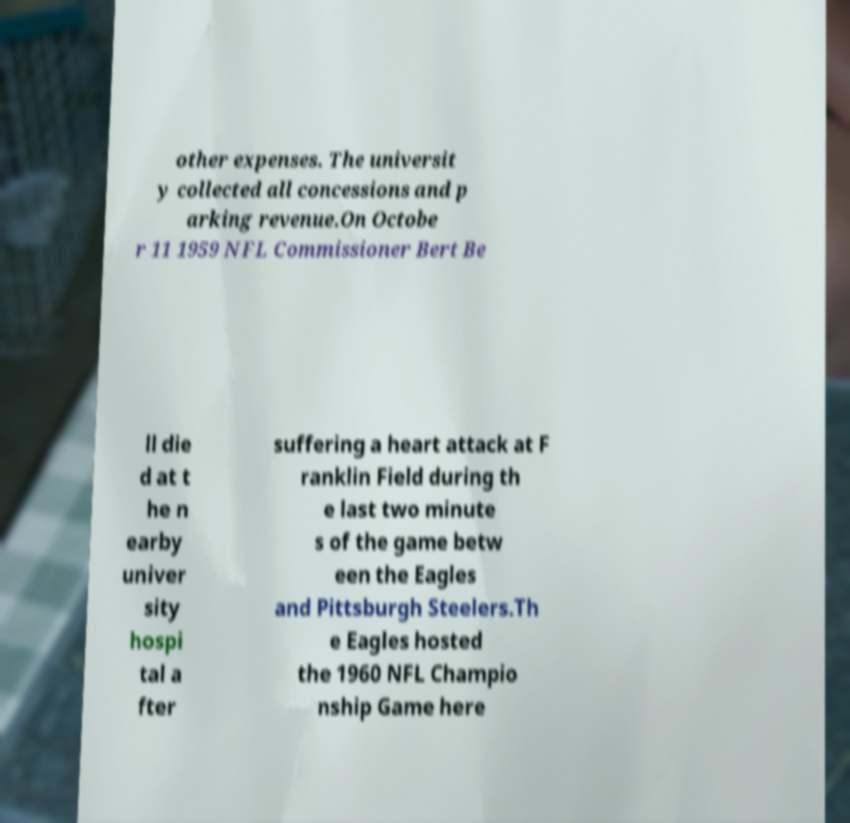Can you accurately transcribe the text from the provided image for me? other expenses. The universit y collected all concessions and p arking revenue.On Octobe r 11 1959 NFL Commissioner Bert Be ll die d at t he n earby univer sity hospi tal a fter suffering a heart attack at F ranklin Field during th e last two minute s of the game betw een the Eagles and Pittsburgh Steelers.Th e Eagles hosted the 1960 NFL Champio nship Game here 